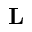<formula> <loc_0><loc_0><loc_500><loc_500>L</formula> 